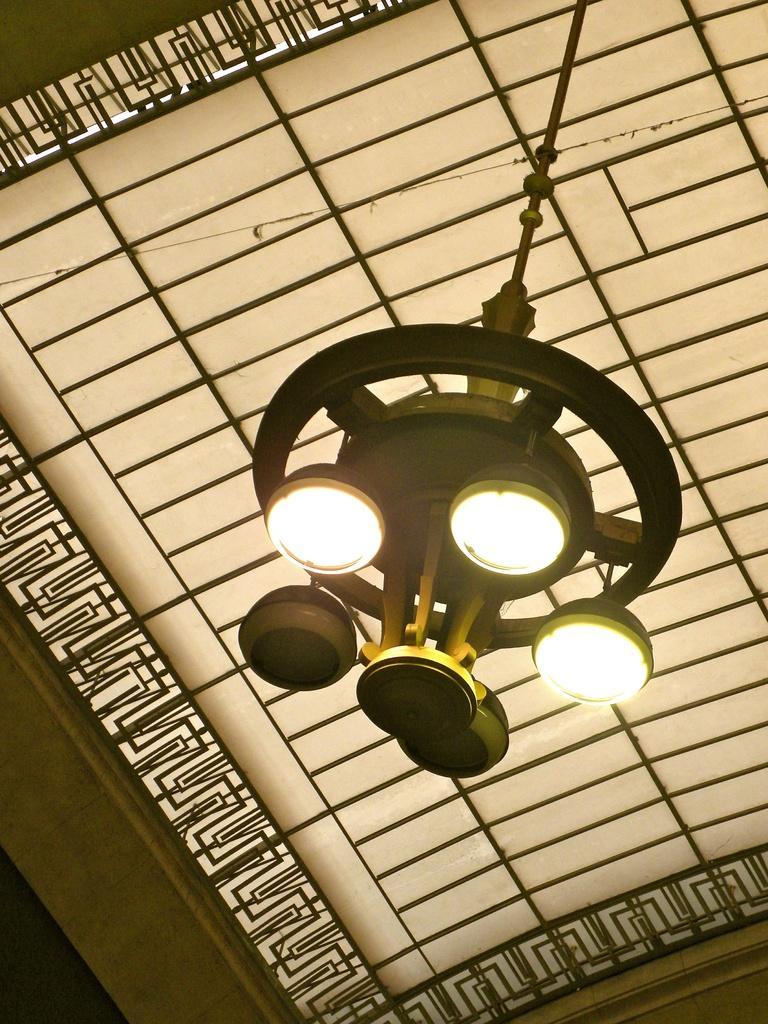Describe this image in one or two sentences. In this image we can see a chandelier with group of lights attached to it. In the background we can see a design. 